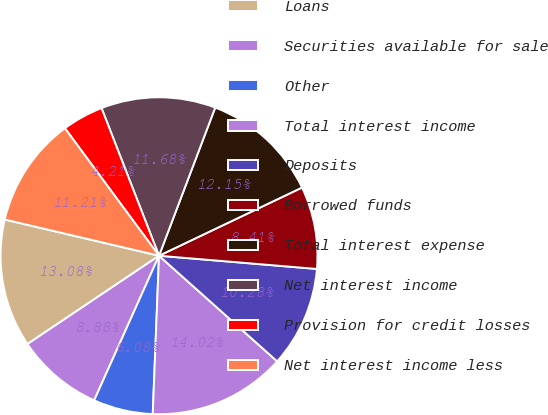<chart> <loc_0><loc_0><loc_500><loc_500><pie_chart><fcel>Loans<fcel>Securities available for sale<fcel>Other<fcel>Total interest income<fcel>Deposits<fcel>Borrowed funds<fcel>Total interest expense<fcel>Net interest income<fcel>Provision for credit losses<fcel>Net interest income less<nl><fcel>13.08%<fcel>8.88%<fcel>6.08%<fcel>14.02%<fcel>10.28%<fcel>8.41%<fcel>12.15%<fcel>11.68%<fcel>4.21%<fcel>11.21%<nl></chart> 